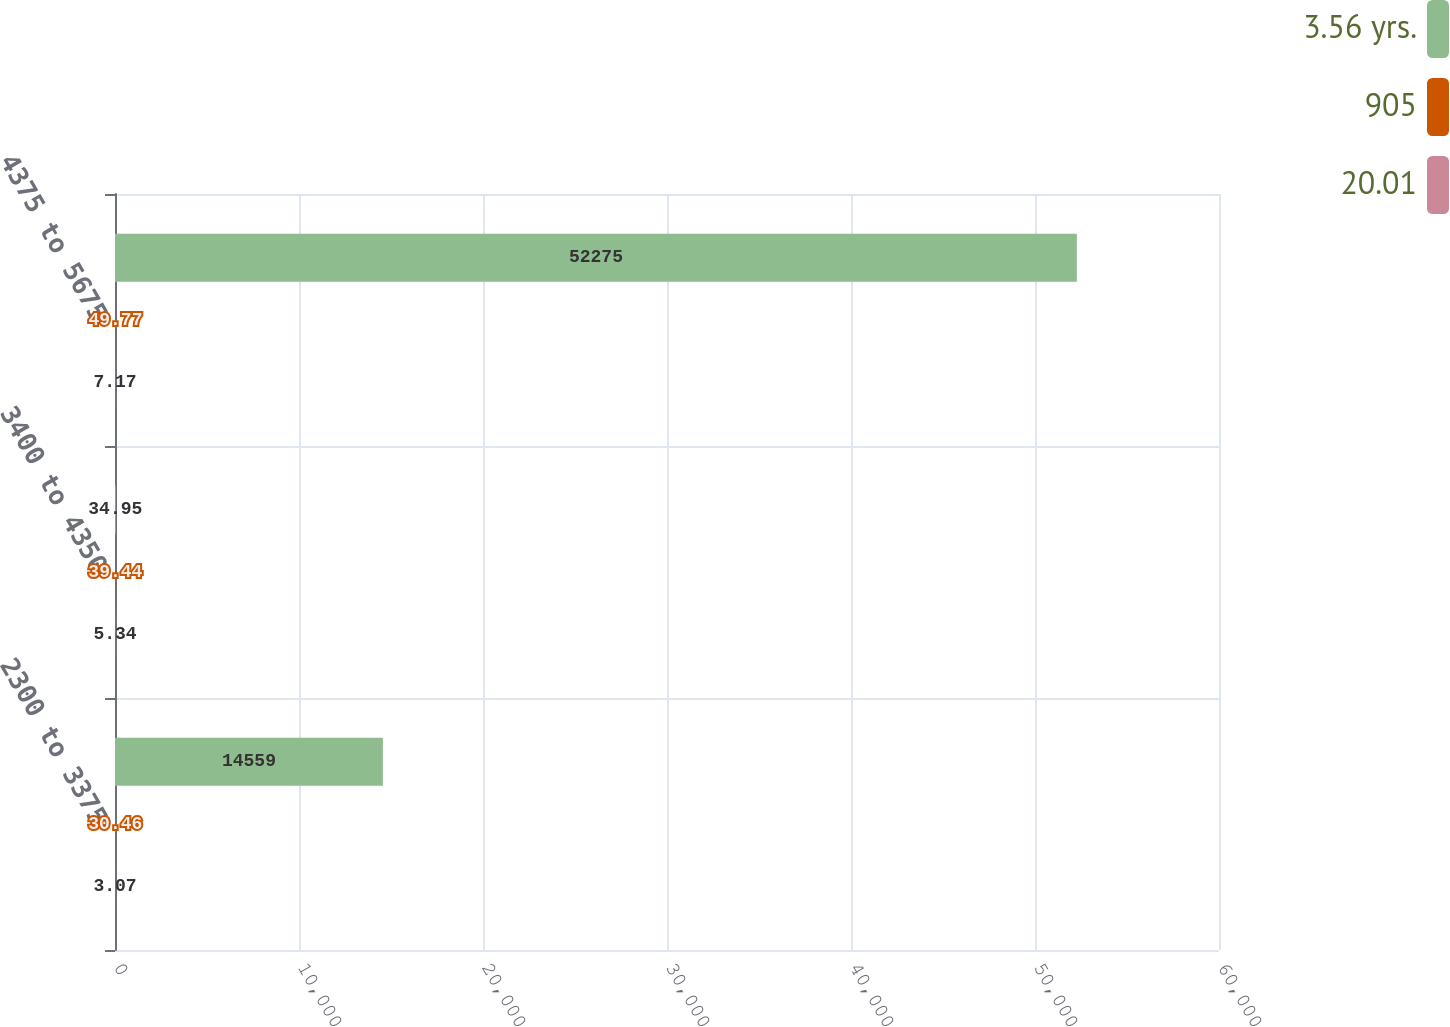Convert chart. <chart><loc_0><loc_0><loc_500><loc_500><stacked_bar_chart><ecel><fcel>2300 to 3375<fcel>3400 to 4350<fcel>4375 to 5675<nl><fcel>3.56 yrs.<fcel>14559<fcel>34.95<fcel>52275<nl><fcel>905<fcel>30.46<fcel>39.44<fcel>49.77<nl><fcel>20.01<fcel>3.07<fcel>5.34<fcel>7.17<nl></chart> 